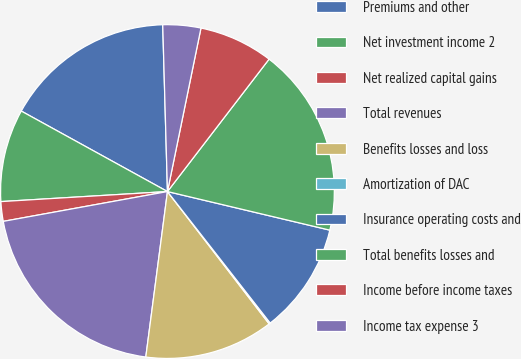Convert chart to OTSL. <chart><loc_0><loc_0><loc_500><loc_500><pie_chart><fcel>Premiums and other<fcel>Net investment income 2<fcel>Net realized capital gains<fcel>Total revenues<fcel>Benefits losses and loss<fcel>Amortization of DAC<fcel>Insurance operating costs and<fcel>Total benefits losses and<fcel>Income before income taxes<fcel>Income tax expense 3<nl><fcel>16.54%<fcel>8.97%<fcel>1.9%<fcel>20.07%<fcel>12.5%<fcel>0.13%<fcel>10.73%<fcel>18.3%<fcel>7.2%<fcel>3.67%<nl></chart> 